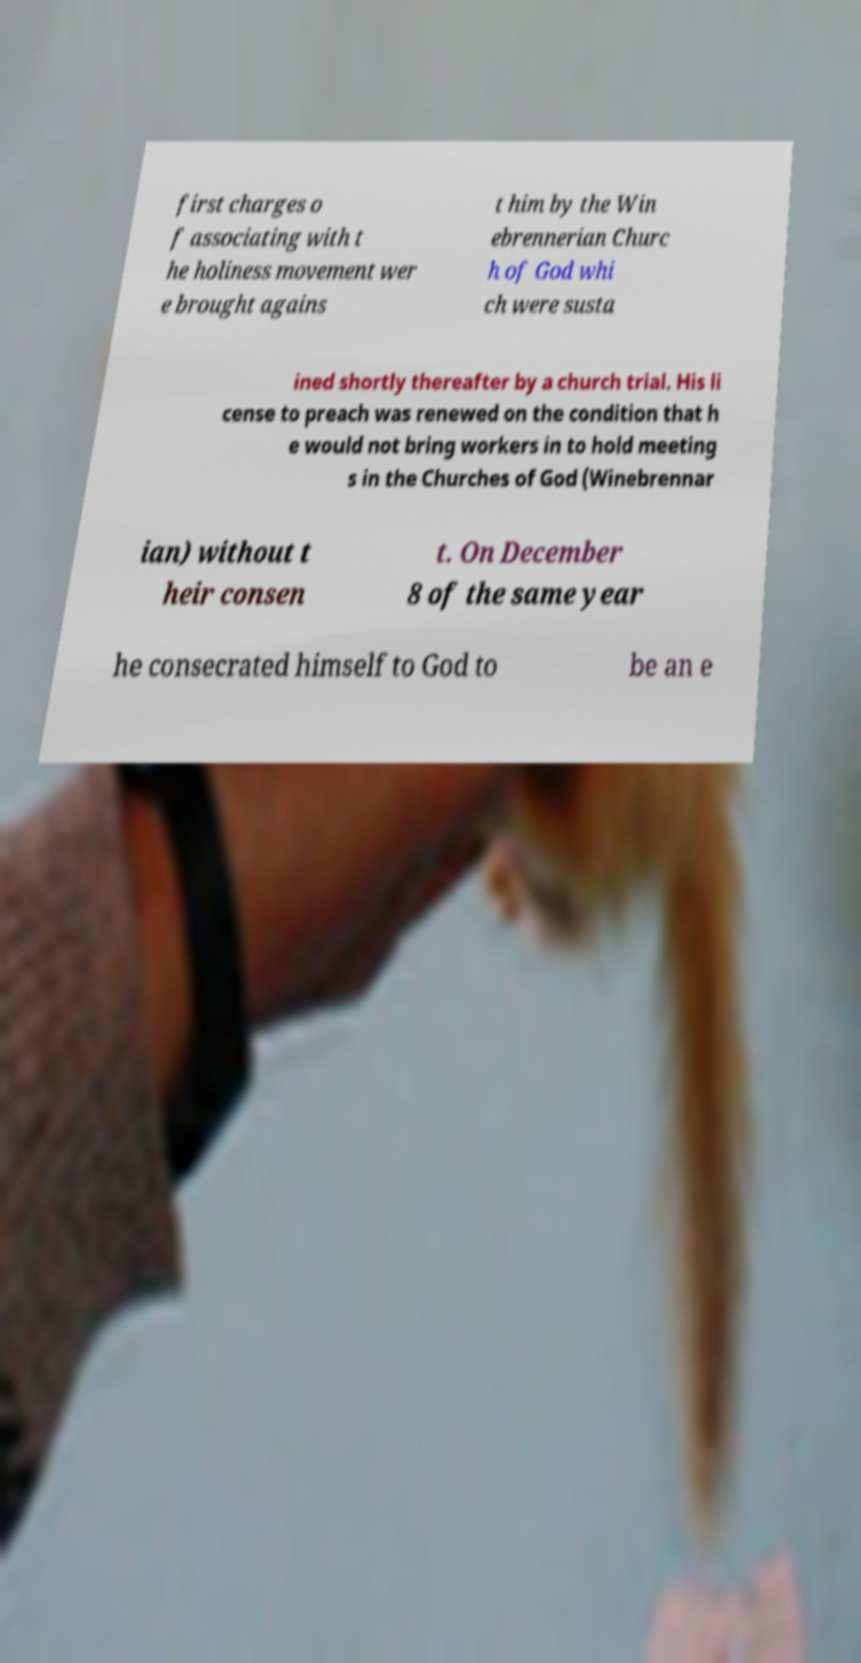Could you extract and type out the text from this image? first charges o f associating with t he holiness movement wer e brought agains t him by the Win ebrennerian Churc h of God whi ch were susta ined shortly thereafter by a church trial. His li cense to preach was renewed on the condition that h e would not bring workers in to hold meeting s in the Churches of God (Winebrennar ian) without t heir consen t. On December 8 of the same year he consecrated himself to God to be an e 